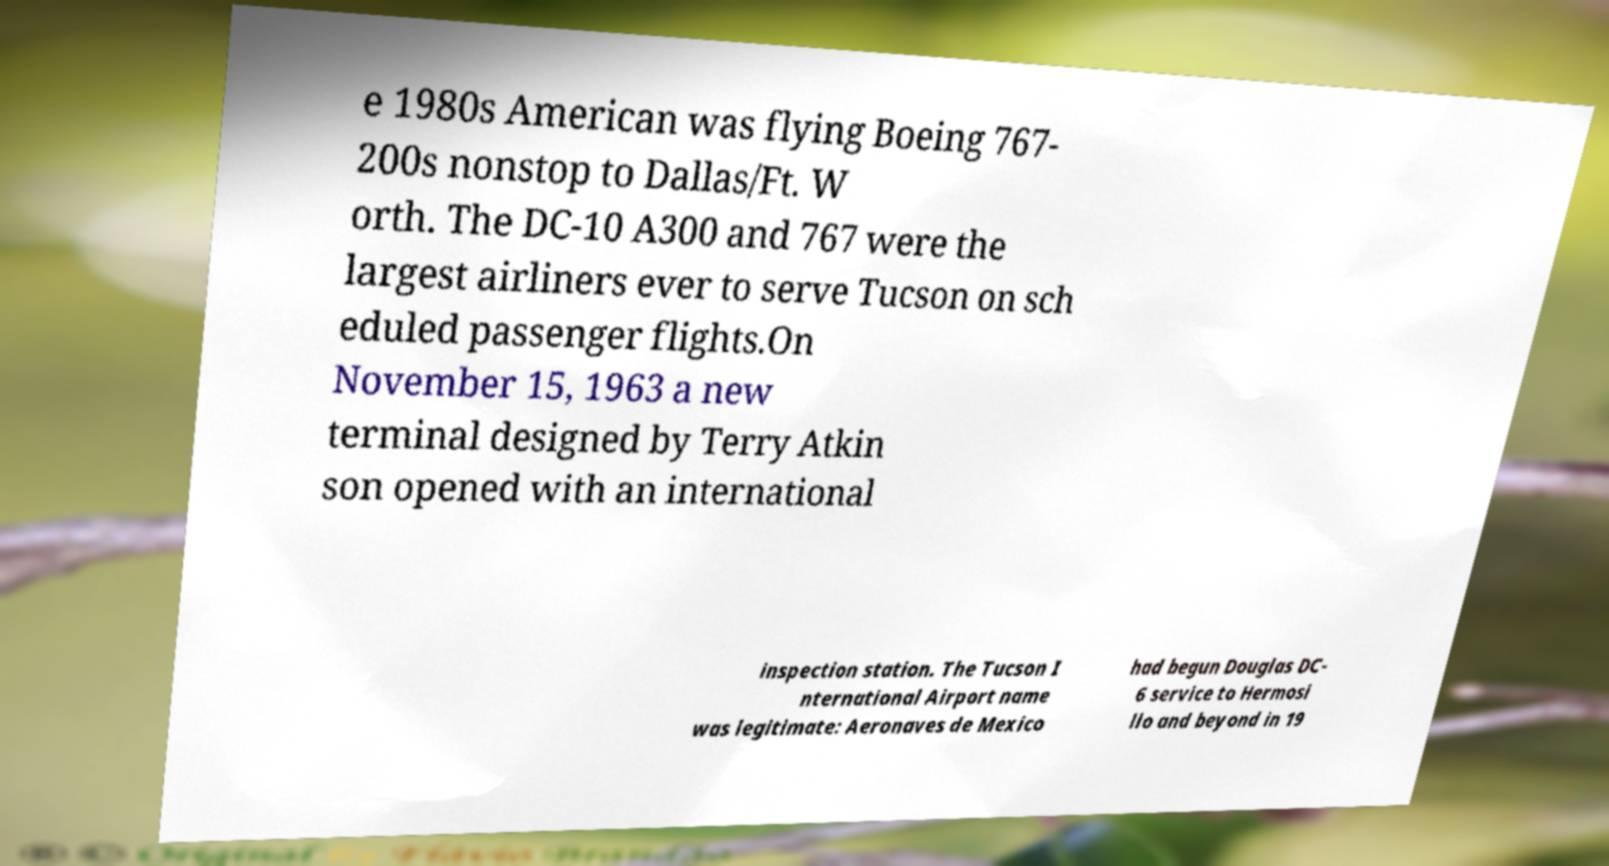Please read and relay the text visible in this image. What does it say? e 1980s American was flying Boeing 767- 200s nonstop to Dallas/Ft. W orth. The DC-10 A300 and 767 were the largest airliners ever to serve Tucson on sch eduled passenger flights.On November 15, 1963 a new terminal designed by Terry Atkin son opened with an international inspection station. The Tucson I nternational Airport name was legitimate: Aeronaves de Mexico had begun Douglas DC- 6 service to Hermosi llo and beyond in 19 